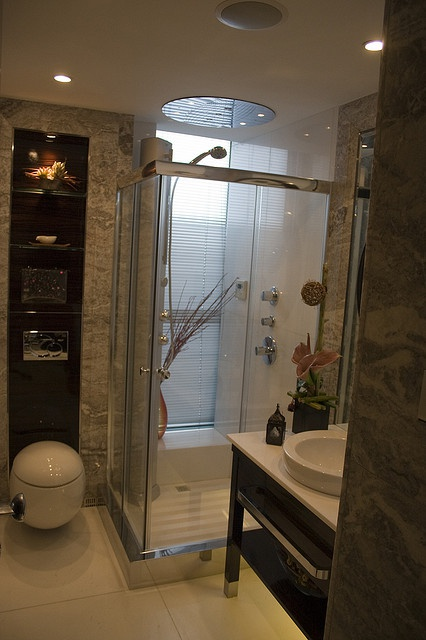Describe the objects in this image and their specific colors. I can see toilet in black, gray, and olive tones, potted plant in black, maroon, and gray tones, sink in black, gray, and tan tones, vase in black and gray tones, and vase in black, maroon, and gray tones in this image. 